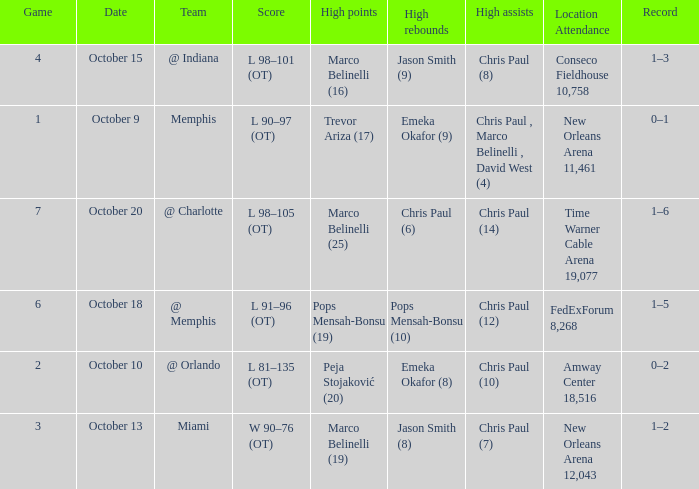What team did the Hornets play in game 4? @ Indiana. 